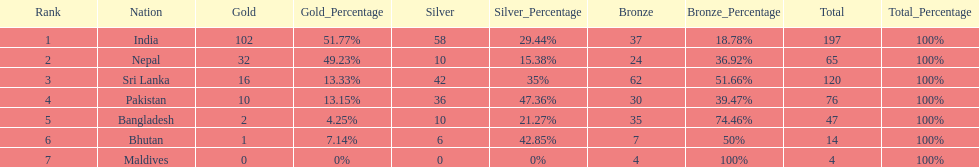Parse the table in full. {'header': ['Rank', 'Nation', 'Gold', 'Gold_Percentage', 'Silver', 'Silver_Percentage', 'Bronze', 'Bronze_Percentage', 'Total', 'Total_Percentage'], 'rows': [['1', 'India', '102', '51.77%', '58', '29.44%', '37', '18.78%', '197', '100%'], ['2', 'Nepal', '32', '49.23%', '10', '15.38%', '24', '36.92%', '65', '100%'], ['3', 'Sri Lanka', '16', '13.33%', '42', '35%', '62', '51.66%', '120', '100%'], ['4', 'Pakistan', '10', '13.15%', '36', '47.36%', '30', '39.47%', '76', '100%'], ['5', 'Bangladesh', '2', '4.25%', '10', '21.27%', '35', '74.46%', '47', '100%'], ['6', 'Bhutan', '1', '7.14%', '6', '42.85%', '7', '50%', '14', '100%'], ['7', 'Maldives', '0', '0%', '0', '0%', '4', '100%', '4', '100%']]} What was the number of silver medals won by pakistan? 36. 